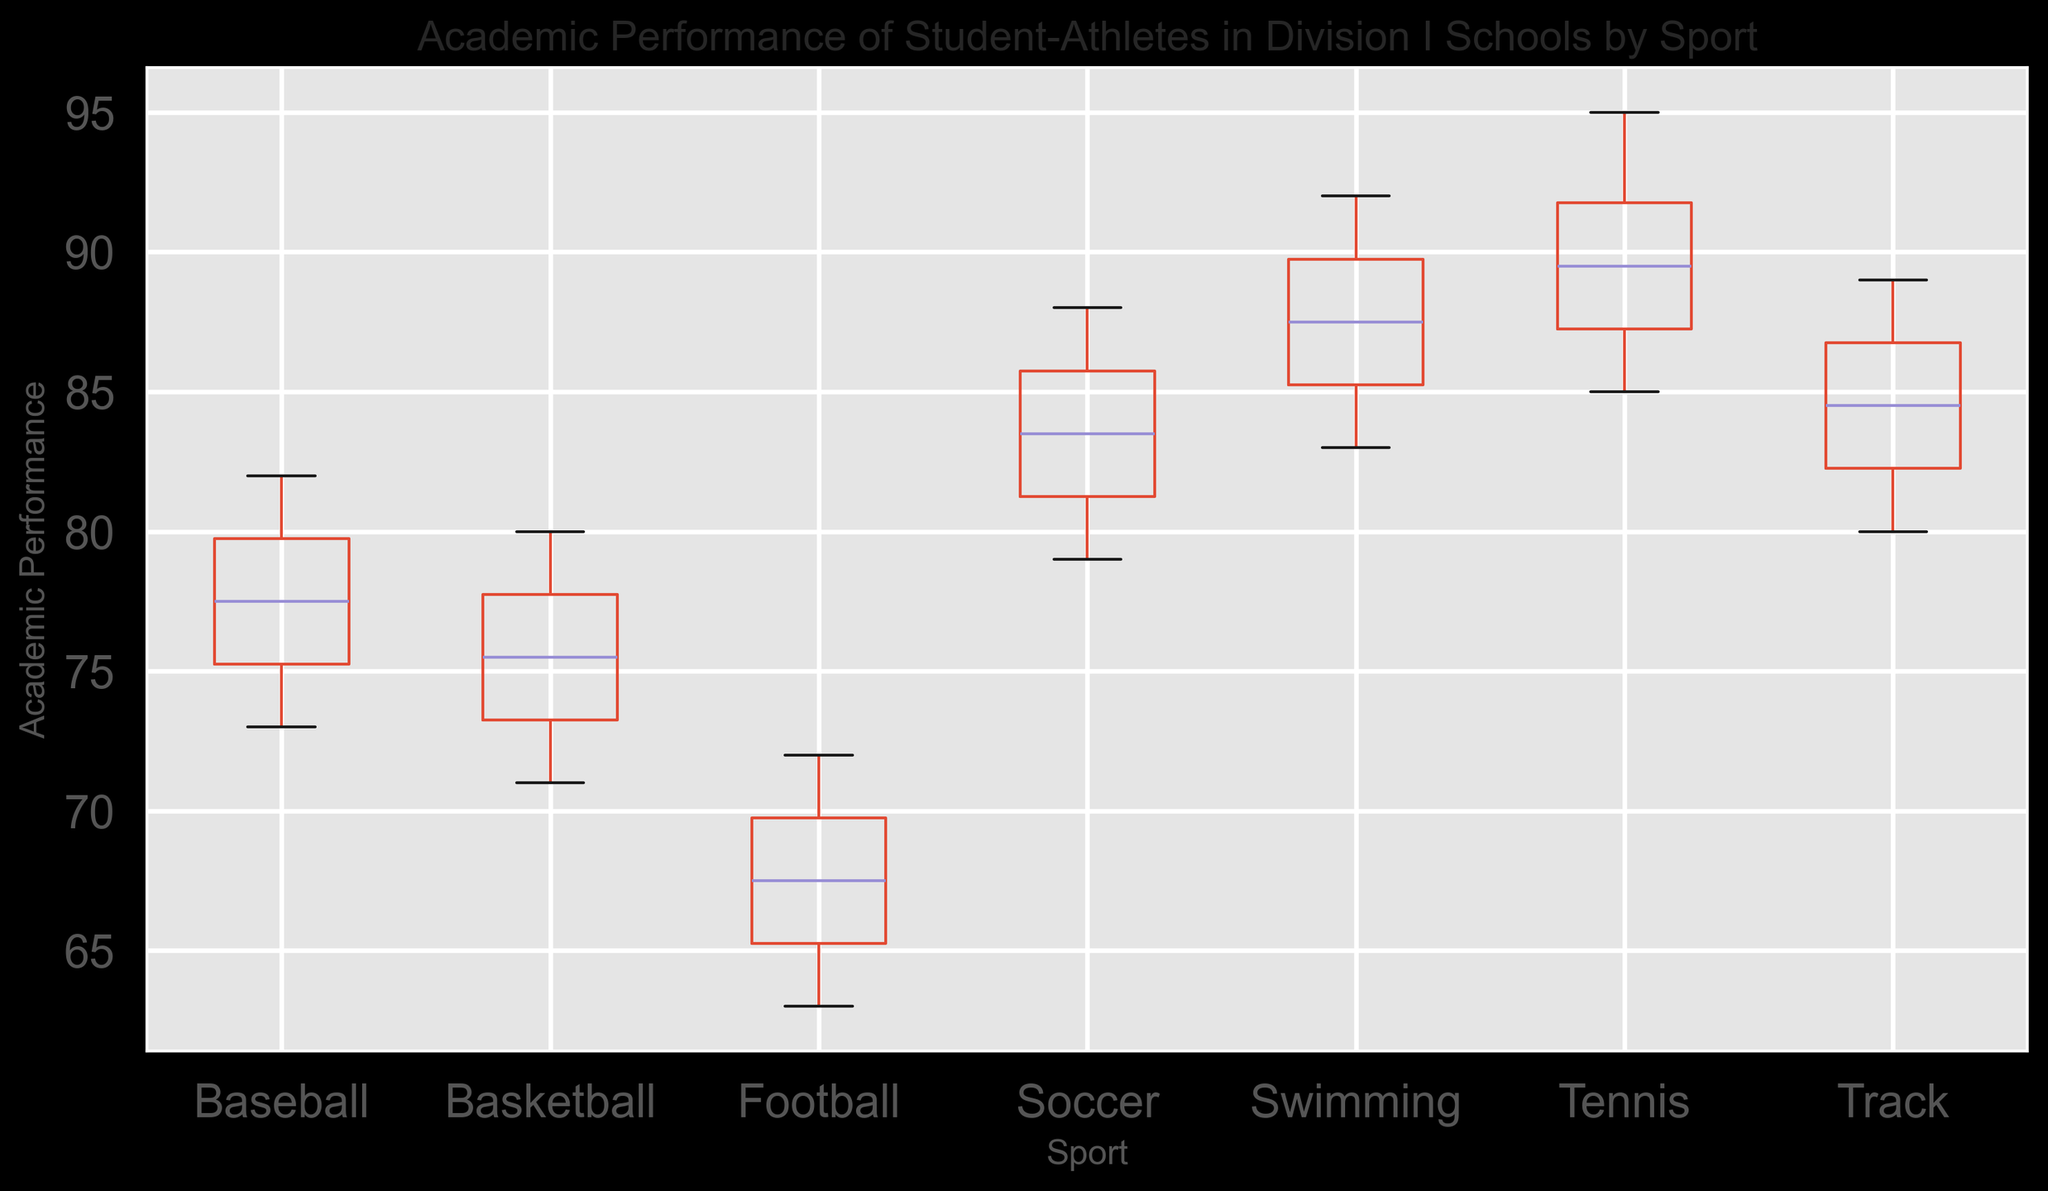What is the median academic performance for Tennis players? The median is the middle value of an ordered list. For Tennis, sort the values: 85, 86, 87, 88, 89, 90, 91, 92, 93, 95. The median is the average of the 5th and 6th values: (89 + 90) / 2 = 89.5
Answer: 89.5 Which sport has the highest median academic performance? To find this, compare the medians of each sport. For Tennis (89.5), Basketball (75.5), Football (67), Soccer (84.5), Baseball (76), Swimming (88), and Track (85). Tennis has the highest median at 89.5
Answer: Tennis What is the interquartile range (IQR) for Soccer players' academic performance? The IQR is the difference between the 75th percentile (upper quartile) and the 25th percentile (lower quartile). For Soccer, sort the values: 79, 80, 81, 82, 83, 84, 85, 86, 87, 88. The lower quartile (Q1) is the 25th percentile: 82. The upper quartile (Q3) is the 75th percentile: 86. IQR = Q3 - Q1 = 86 - 82 = 4
Answer: 4 Are there any outliers in the academic performance of Football players? Outliers in a box plot are typically represented by points outside the whiskers. For Football, if the range is represented well within the whiskers, there are no outliers. If any points fall outside the whiskers, these are considered outliers. Based on standard description, Football's range seems within bounds, and no outlier points are mentioned
Answer: No Which sport has the widest range of academic performance values? The range is the difference between the maximum and minimum values. For Tennis (95 - 85 = 10), Basketball (80 - 71 = 9), Football (72 - 63 = 9), Soccer (88 - 79 = 9), Baseball (82 - 73 = 9), Swimming (92 - 83 = 9), and Track (89 - 80 = 9). Tennis has the widest range at 10
Answer: Tennis How does the academic performance of Basketball players compare to that of Baseball players? Compare the medians and the spread (IQR) of each sport. The median for Basketball is 75.5 and the IQR is 79 - 73 = 6. For Baseball, the median is 76 and the IQR is 80 - 74 = 6. The medians are very close, indicating similar performance
Answer: Similar Which sport shows the greatest variability in academic performance? Variability can be assessed by looking at the spread (IQR). Tennis (8), Basketball (6), Football (7), Soccer (6), Baseball (6), Swimming (7), and Track (8). Both Tennis and Track have IQRs of 8, the greatest variability
Answer: Tennis and Track 